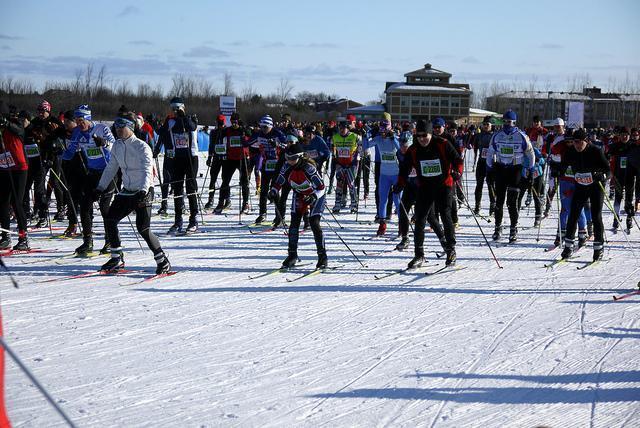How many people are visible?
Give a very brief answer. 6. 